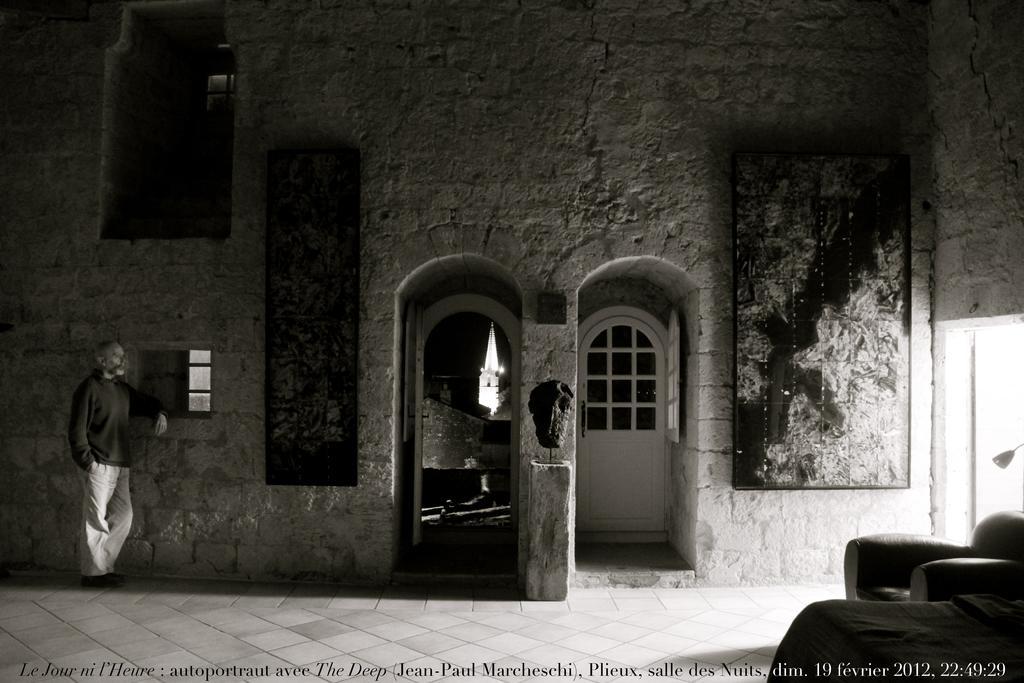Can you describe this image briefly? In this picture there is a man who is standing on the left side of the image and there is sofa and a lamp in the bottom right side of the image and there are doors and portraits in the center of the image. 